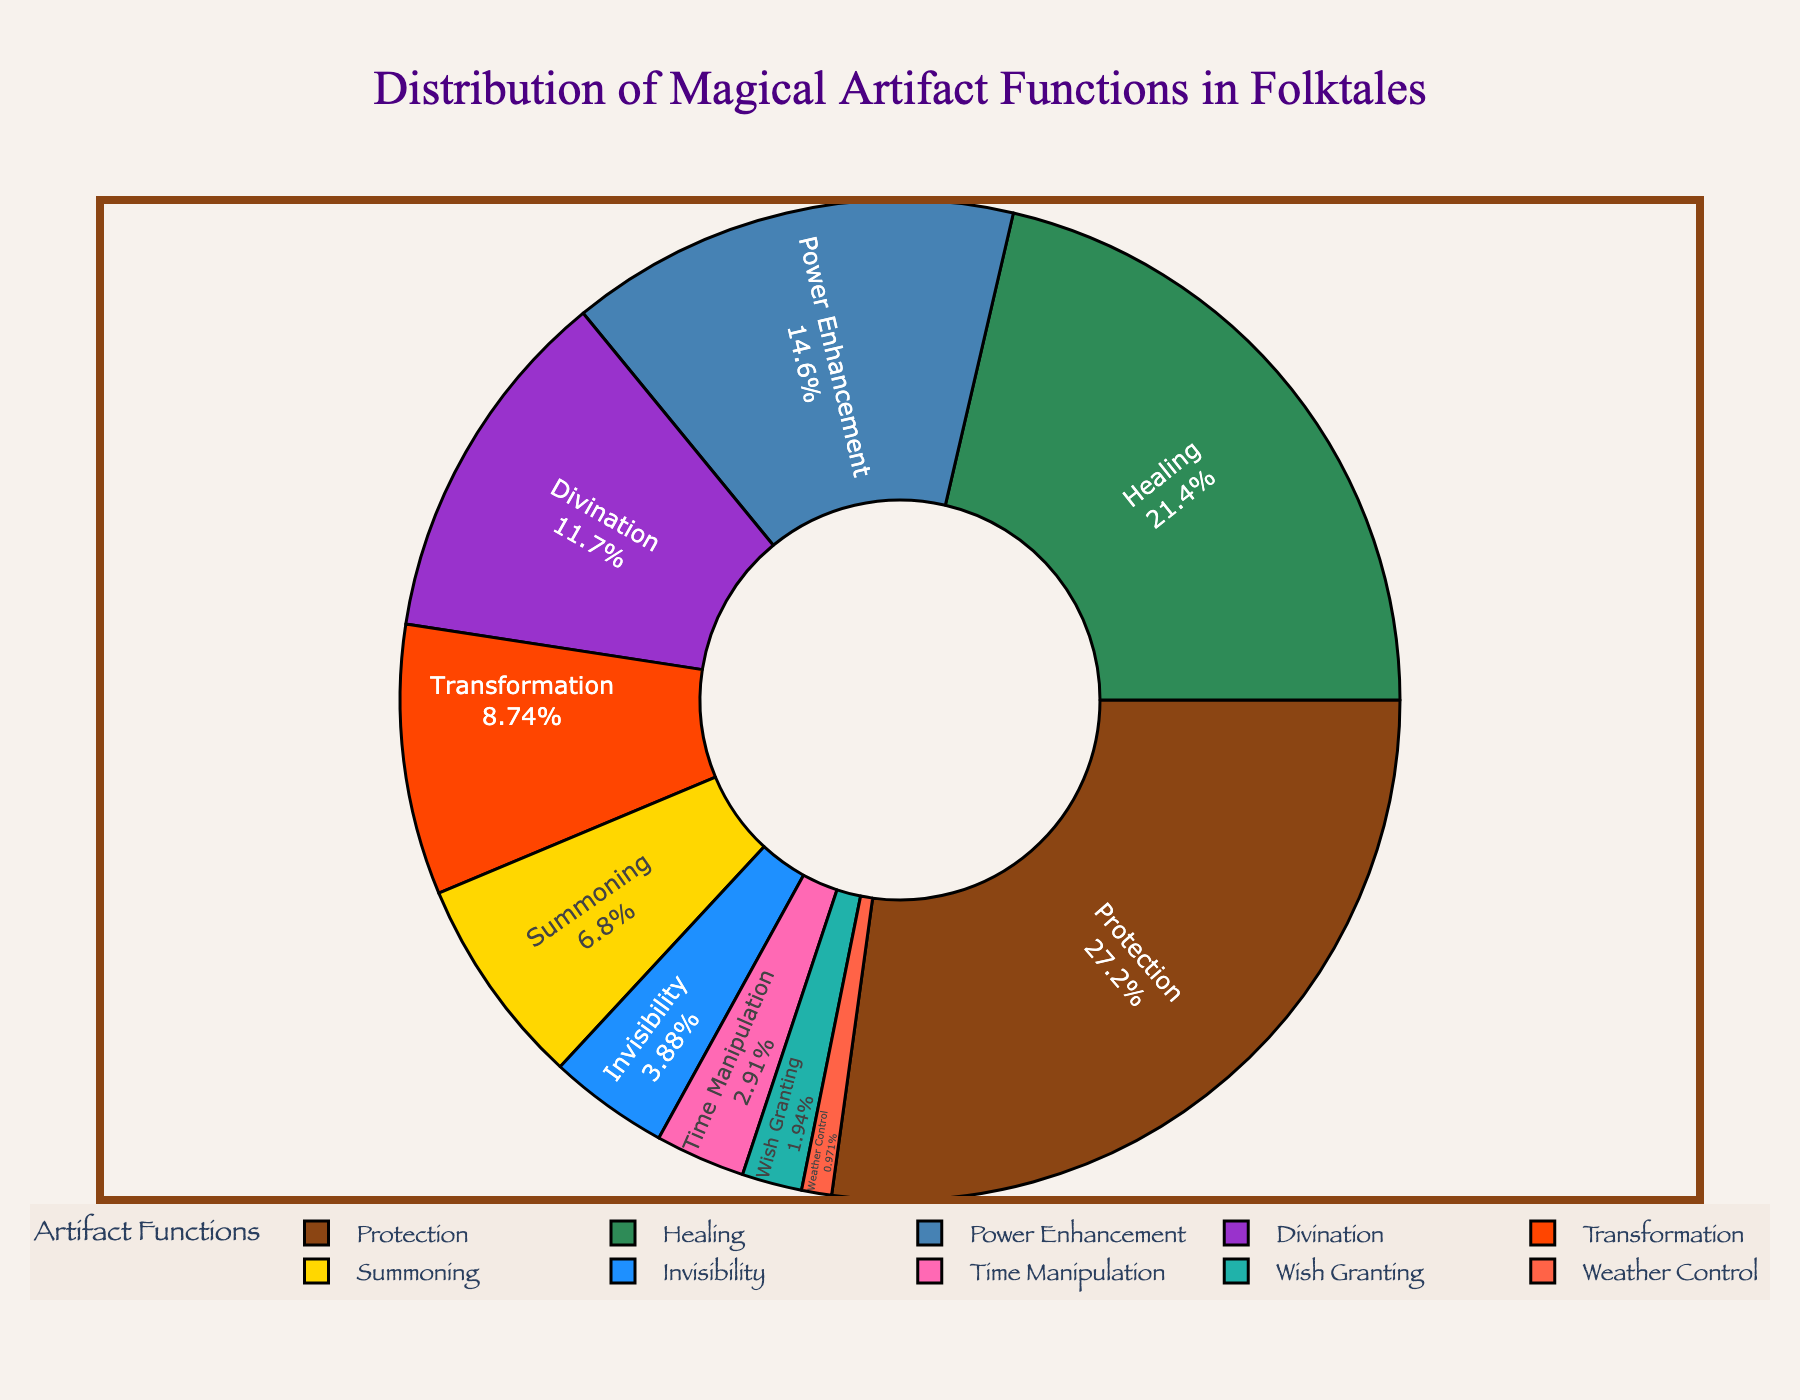What is the largest function category in the pie chart? The pie chart shows the different functions of magical artifacts and their respective percentages. The largest segment, which corresponds to the "Protection" function, occupies the most space. This is indicated by the label showing 28% for Protection.
Answer: Protection Which two functions have the smallest percentage? By observing the pie chart, we can identify the smallest segments. The segments for "Wish Granting" and "Weather Control" are the smallest, with percentages of 2% and 1%, respectively.
Answer: Wish Granting and Weather Control What is the total percentage of functions related to "Protection" and "Healing"? Adding the percentages for Protection (28%) and Healing (22%), the total is 28% + 22% = 50%.
Answer: 50% How does the percentage of "Power Enhancement" compare to "Summoning"? The percentages for Power Enhancement and Summoning can be compared directly. Power Enhancement is at 15%, while Summoning is at 7%. Therefore, Power Enhancement has a higher percentage.
Answer: Power Enhancement is higher Which function has a greater percentage: "Invisibility" or "Time Manipulation"? By locating the percentages for both Invisibility and Time Manipulation on the pie chart, we see that Invisibility is at 4% and Time Manipulation is at 3%. Hence, Invisibility has a greater percentage.
Answer: Invisibility What is the combined percentage of the three least common functions? The three least common functions are "Wish Granting" (2%), "Weather Control" (1%), and "Time Manipulation" (3%). Adding these together gives 2% + 1% + 3% = 6%.
Answer: 6% What is the percentage difference between "Protection" and "Transformation"? The percentage for Protection is 28%, and for Transformation, it is 9%. The difference is calculated as 28% - 9% = 19%.
Answer: 19% Is the percentage of "Healing" more than double that of "Divination"? The percentage for Healing is 22%, and for Divination, it is 12%. Doubling the percentage for Divination gives 12% * 2 = 24%. Since 22% is less than 24%, Healing is not more than double of Divination.
Answer: No If "Healing" and "Power Enhancement" are combined, what percentage of the total do they represent? Adding the percentages for Healing (22%) and Power Enhancement (15%), we get 22% + 15% = 37%.
Answer: 37% What function is represented by the color blue in the pie chart? By analyzing the color legend and the segments, we can see that the blue segment represents "Divination" which is mentioned along with 12%.
Answer: Divination 